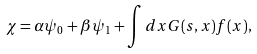<formula> <loc_0><loc_0><loc_500><loc_500>\chi = \alpha \psi _ { 0 } + \beta \psi _ { 1 } + \int d x G ( s , x ) f ( x ) ,</formula> 